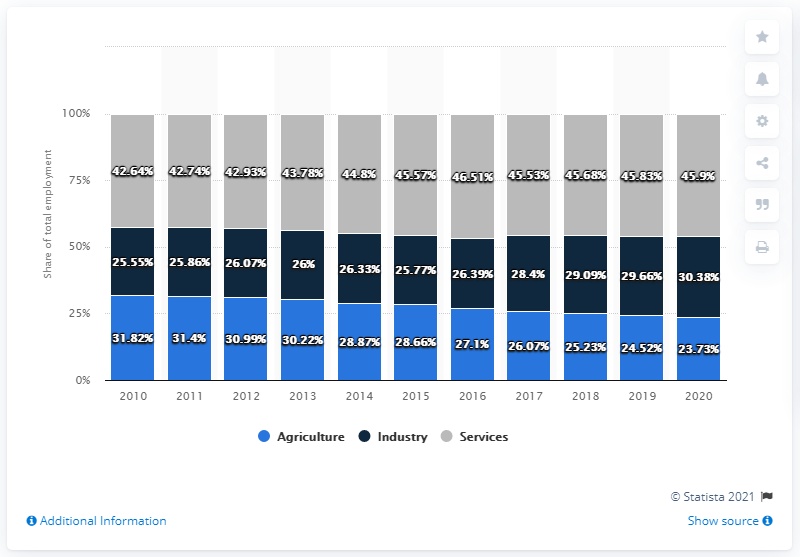Give some essential details in this illustration. In 2010, the services sector accounted for approximately 42.64% of the total economic sector. In 2010, the total percentage of the economy that was dedicated to services and industry was 68.19%. 